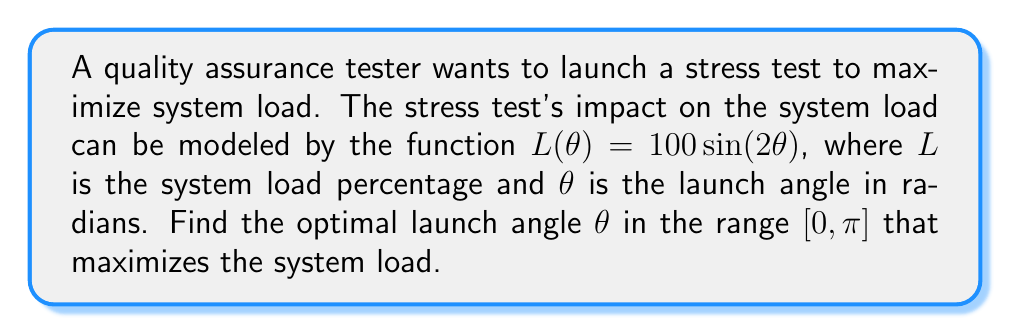What is the answer to this math problem? 1) To find the maximum value of $L(\theta)$, we need to find the critical points by taking the derivative and setting it equal to zero:

   $\frac{d}{d\theta}L(\theta) = 100 \cdot 2\cos(2\theta) = 200\cos(2\theta)$

2) Set the derivative to zero:
   $200\cos(2\theta) = 0$
   $\cos(2\theta) = 0$

3) Solve for $\theta$ in the range $[0, \pi]$:
   $2\theta = \frac{\pi}{2}$ or $2\theta = \frac{3\pi}{2}$
   $\theta = \frac{\pi}{4}$ or $\theta = \frac{3\pi}{4}$

4) To determine which angle gives the maximum, we can evaluate $L(\theta)$ at both points:
   $L(\frac{\pi}{4}) = 100\sin(2\cdot\frac{\pi}{4}) = 100\sin(\frac{\pi}{2}) = 100$
   $L(\frac{3\pi}{4}) = 100\sin(2\cdot\frac{3\pi}{4}) = 100\sin(\frac{3\pi}{2}) = -100$

5) The maximum value occurs at $\theta = \frac{\pi}{4}$ radians.

6) Convert to degrees: $\frac{\pi}{4}$ radians = $45°$
Answer: $45°$ 